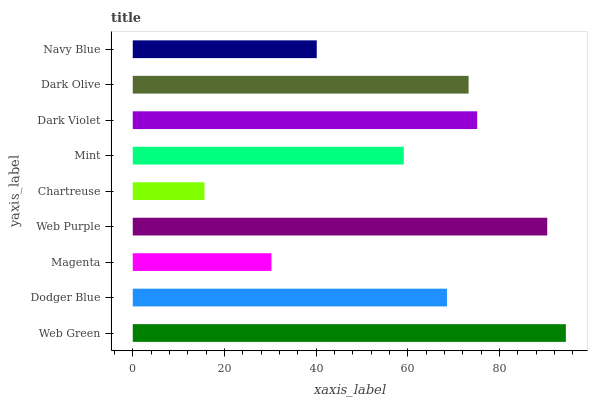Is Chartreuse the minimum?
Answer yes or no. Yes. Is Web Green the maximum?
Answer yes or no. Yes. Is Dodger Blue the minimum?
Answer yes or no. No. Is Dodger Blue the maximum?
Answer yes or no. No. Is Web Green greater than Dodger Blue?
Answer yes or no. Yes. Is Dodger Blue less than Web Green?
Answer yes or no. Yes. Is Dodger Blue greater than Web Green?
Answer yes or no. No. Is Web Green less than Dodger Blue?
Answer yes or no. No. Is Dodger Blue the high median?
Answer yes or no. Yes. Is Dodger Blue the low median?
Answer yes or no. Yes. Is Chartreuse the high median?
Answer yes or no. No. Is Navy Blue the low median?
Answer yes or no. No. 